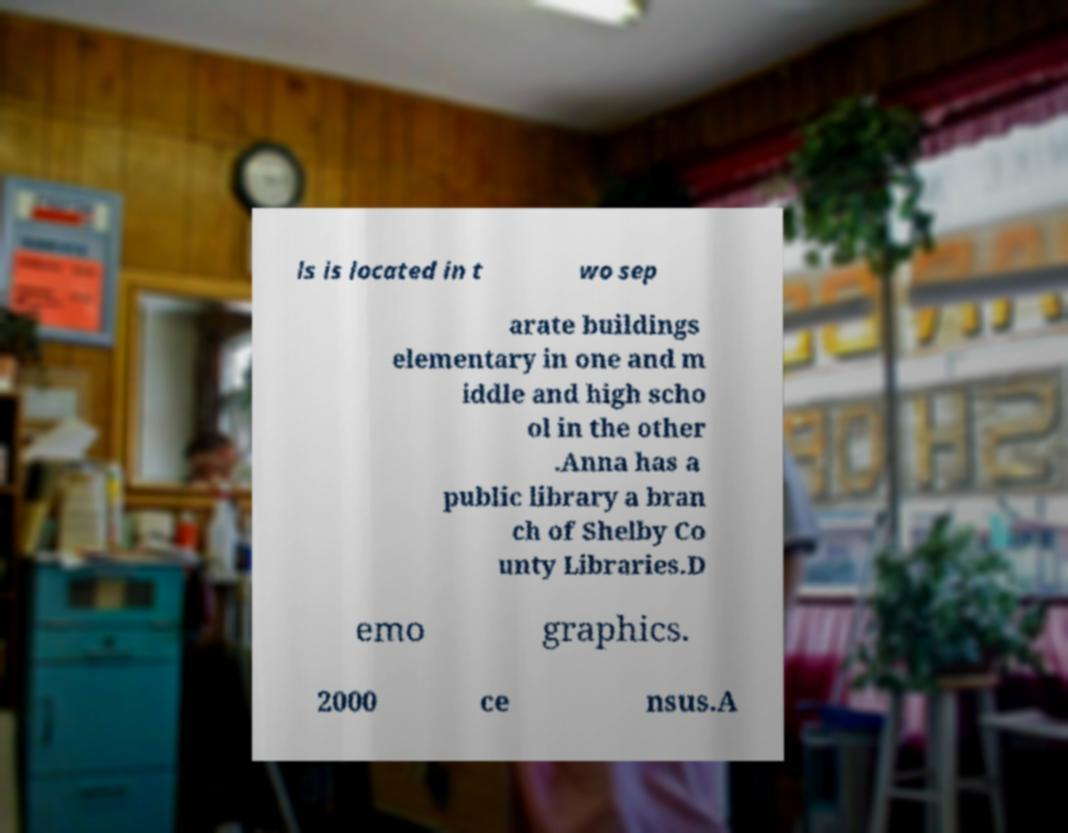Can you accurately transcribe the text from the provided image for me? ls is located in t wo sep arate buildings elementary in one and m iddle and high scho ol in the other .Anna has a public library a bran ch of Shelby Co unty Libraries.D emo graphics. 2000 ce nsus.A 